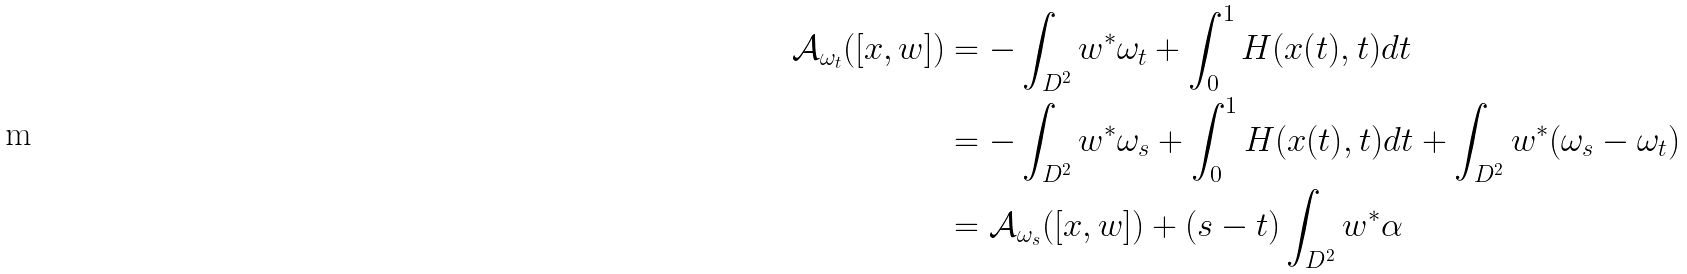<formula> <loc_0><loc_0><loc_500><loc_500>\mathcal { A } _ { \omega _ { t } } ( [ x , w ] ) & = - \int _ { D ^ { 2 } } w ^ { * } \omega _ { t } + \int _ { 0 } ^ { 1 } H ( x ( t ) , t ) d t \\ & = - \int _ { D ^ { 2 } } w ^ { * } \omega _ { s } + \int _ { 0 } ^ { 1 } H ( x ( t ) , t ) d t + \int _ { D ^ { 2 } } w ^ { * } ( \omega _ { s } - \omega _ { t } ) \\ & = \mathcal { A } _ { \omega _ { s } } ( [ x , w ] ) + ( s - t ) \int _ { D ^ { 2 } } w ^ { * } \alpha</formula> 